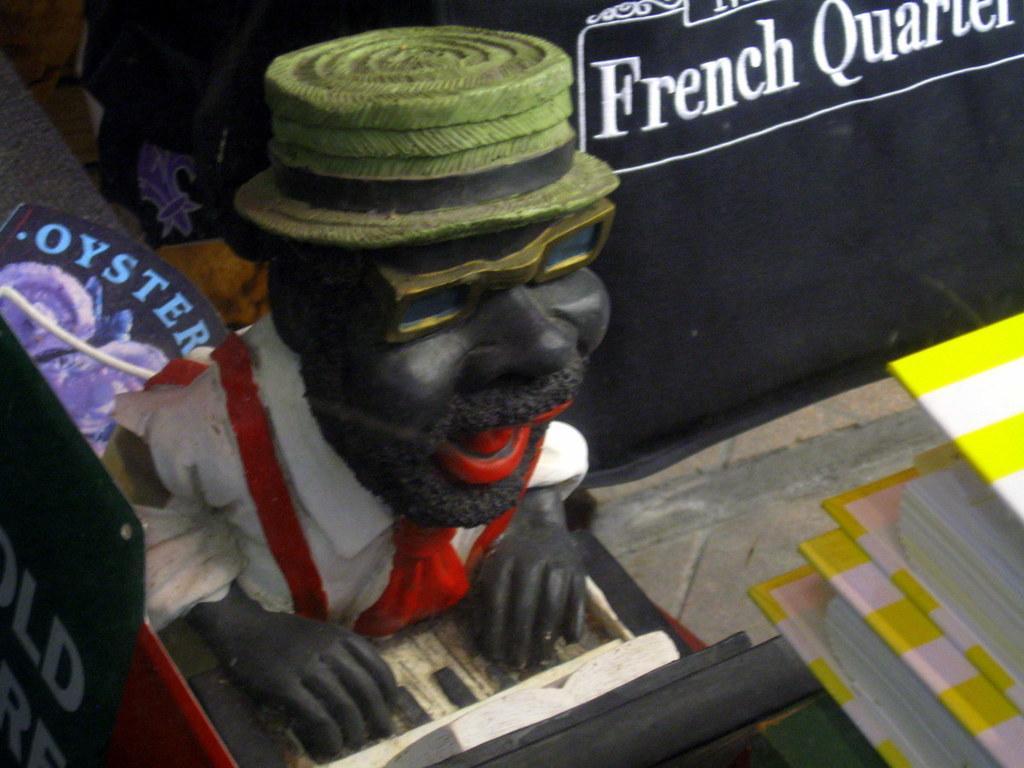How would you summarize this image in a sentence or two? In this picture we can see a statue of a person on the platform, where we can see boards and some objects. 